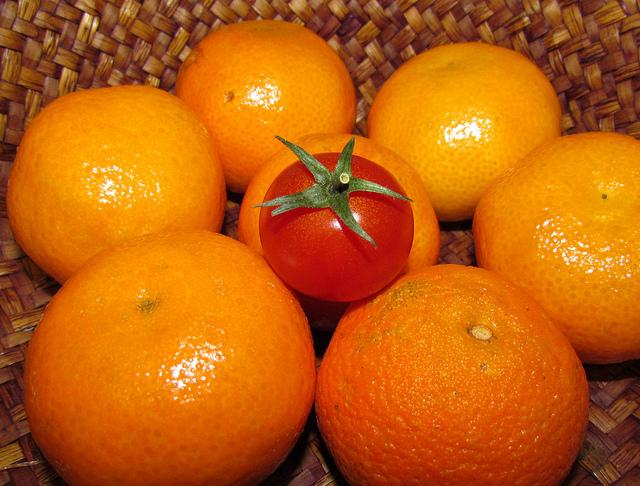Are these oranges?
Give a very brief answer. Yes. What are the fruits sitting in?
Give a very brief answer. Basket. How many types of fruit are there?
Quick response, please. 2. 